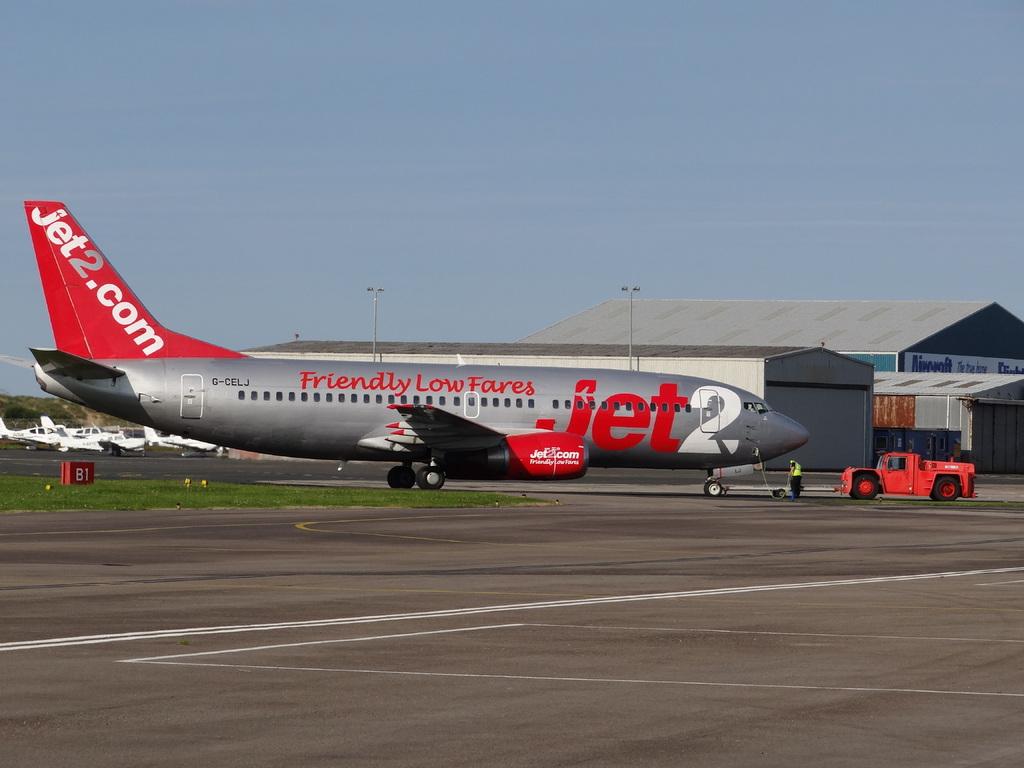What does this plane offer?
Give a very brief answer. Friendly low fares. What airline is this?
Ensure brevity in your answer.  Jet2. 